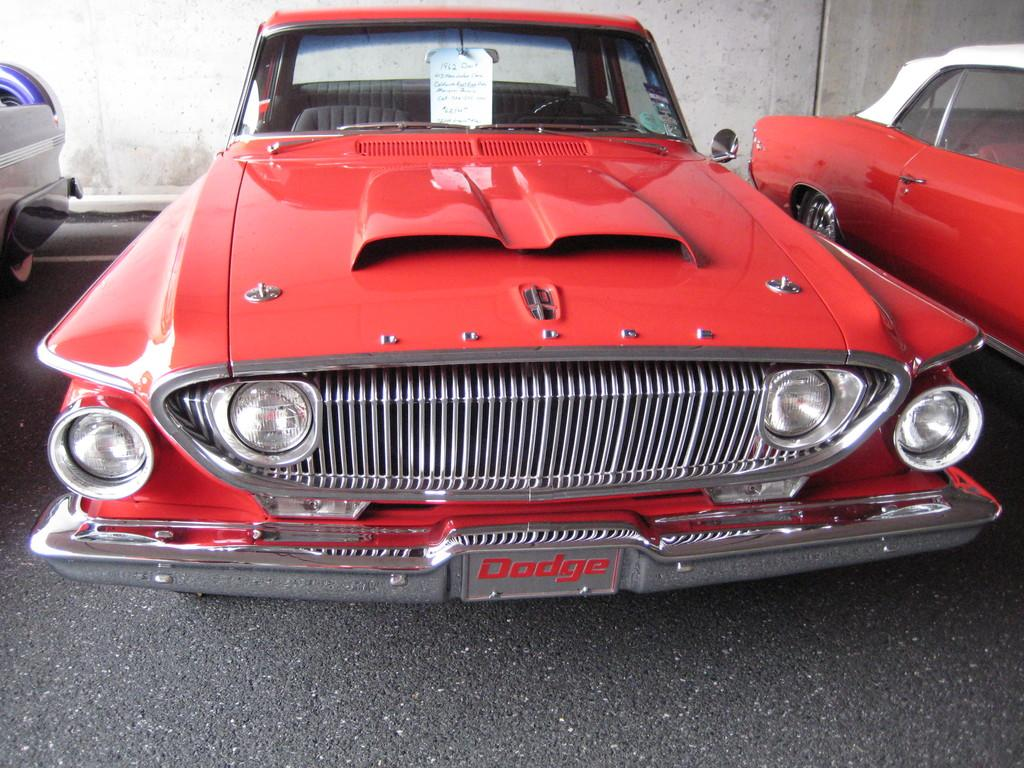What type of vehicles can be seen on the road in the image? There are cars on the road in the image. What is located behind the cars in the image? There is a wall visible behind the cars. What shape is the throat of the person driving the car in the image? There is no person driving the car in the image, and therefore no throat is visible. 